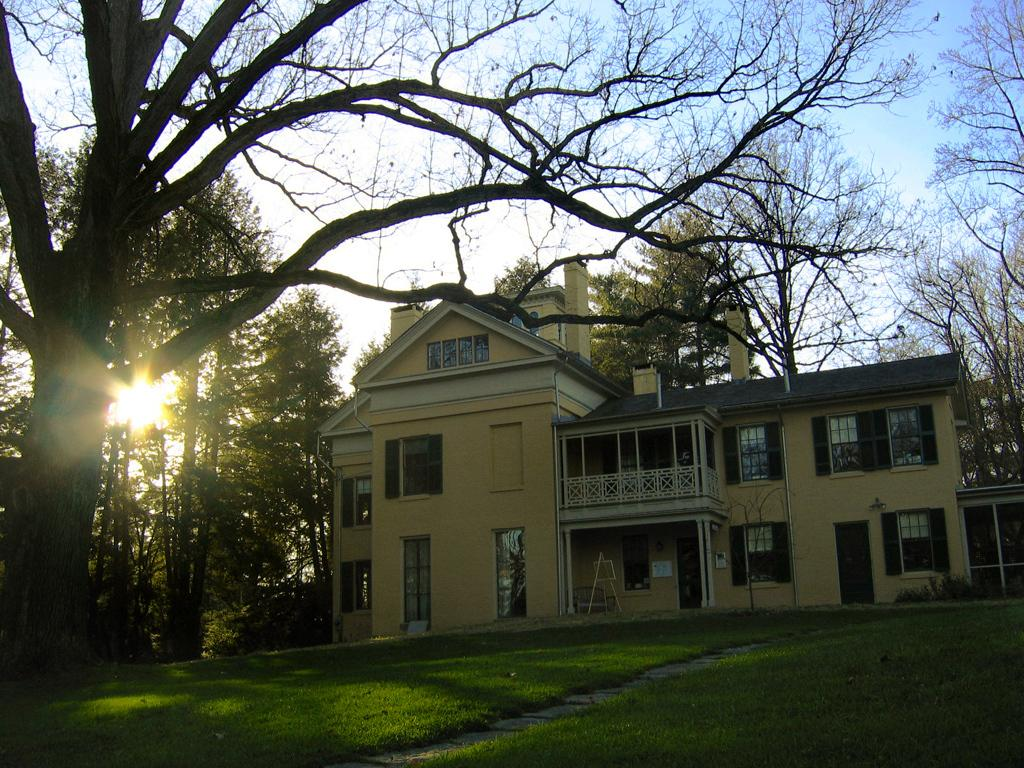What is the main feature of the landscape in the image? There are many trees in the image. What type of structure can be seen in the image? There is a building with railing in the image. What are some features of the building? The building has windows. What can be seen in the background of the image? The sun and the sky are visible in the background of the image. Can you see any giants playing a guitar in the image? There are no giants or guitars present in the image. What color is the orange in the image? There is no orange present in the image. 